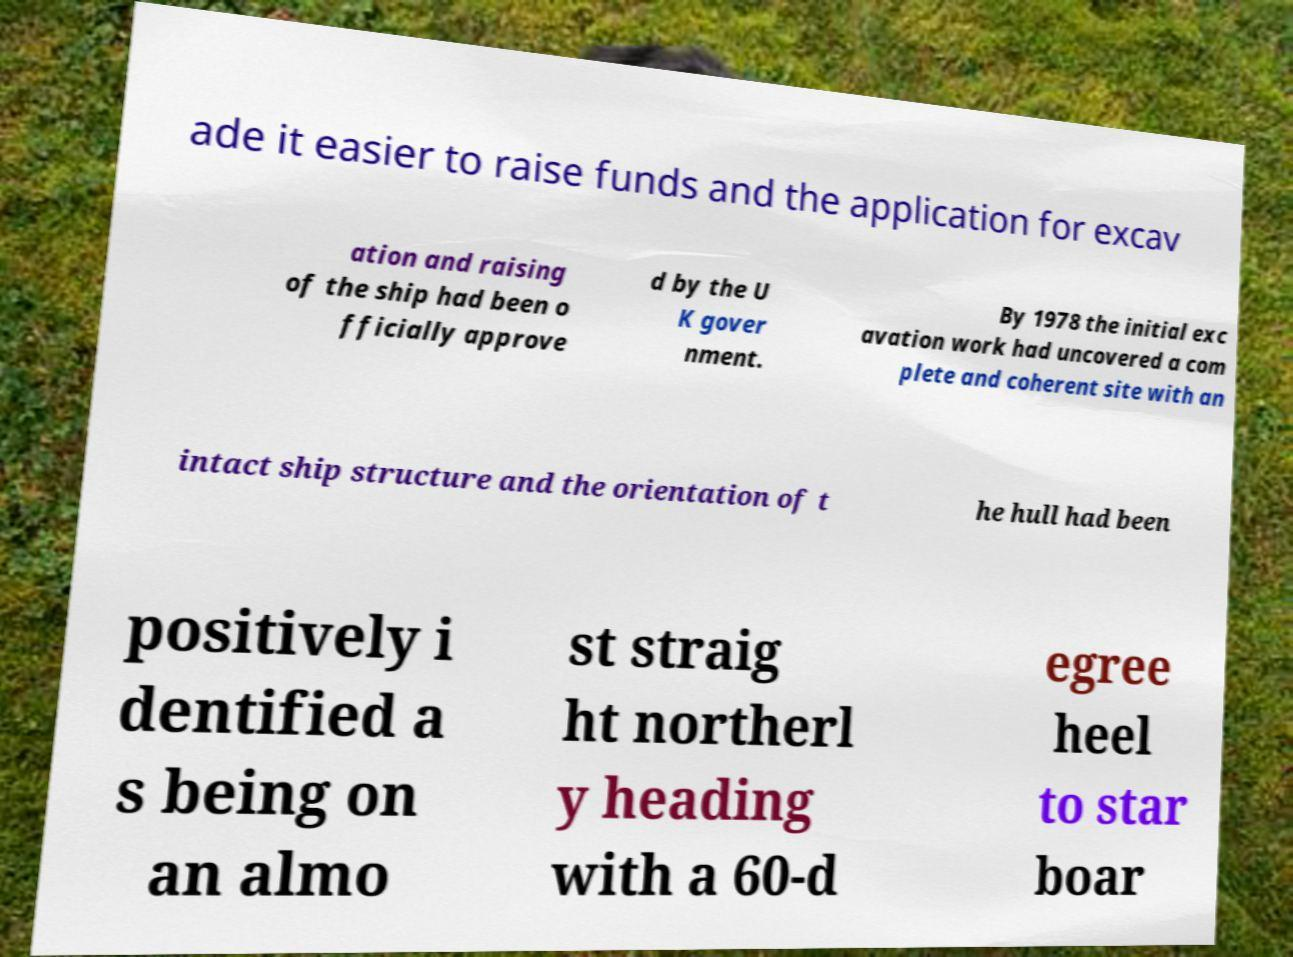What messages or text are displayed in this image? I need them in a readable, typed format. ade it easier to raise funds and the application for excav ation and raising of the ship had been o fficially approve d by the U K gover nment. By 1978 the initial exc avation work had uncovered a com plete and coherent site with an intact ship structure and the orientation of t he hull had been positively i dentified a s being on an almo st straig ht northerl y heading with a 60-d egree heel to star boar 